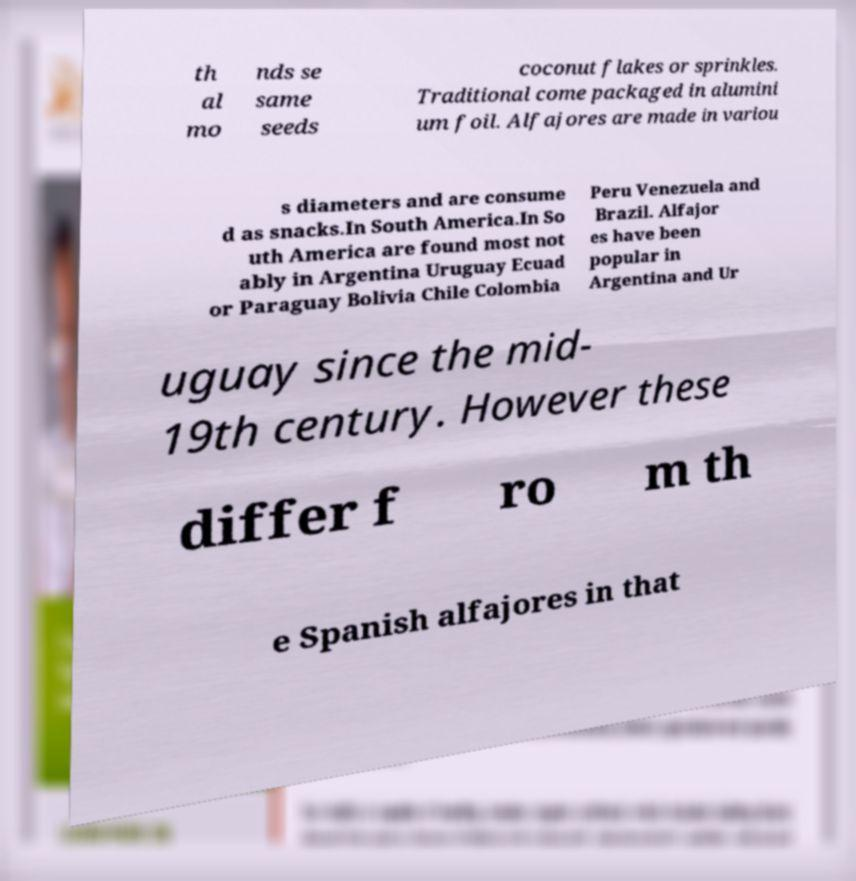Please read and relay the text visible in this image. What does it say? th al mo nds se same seeds coconut flakes or sprinkles. Traditional come packaged in alumini um foil. Alfajores are made in variou s diameters and are consume d as snacks.In South America.In So uth America are found most not ably in Argentina Uruguay Ecuad or Paraguay Bolivia Chile Colombia Peru Venezuela and Brazil. Alfajor es have been popular in Argentina and Ur uguay since the mid- 19th century. However these differ f ro m th e Spanish alfajores in that 